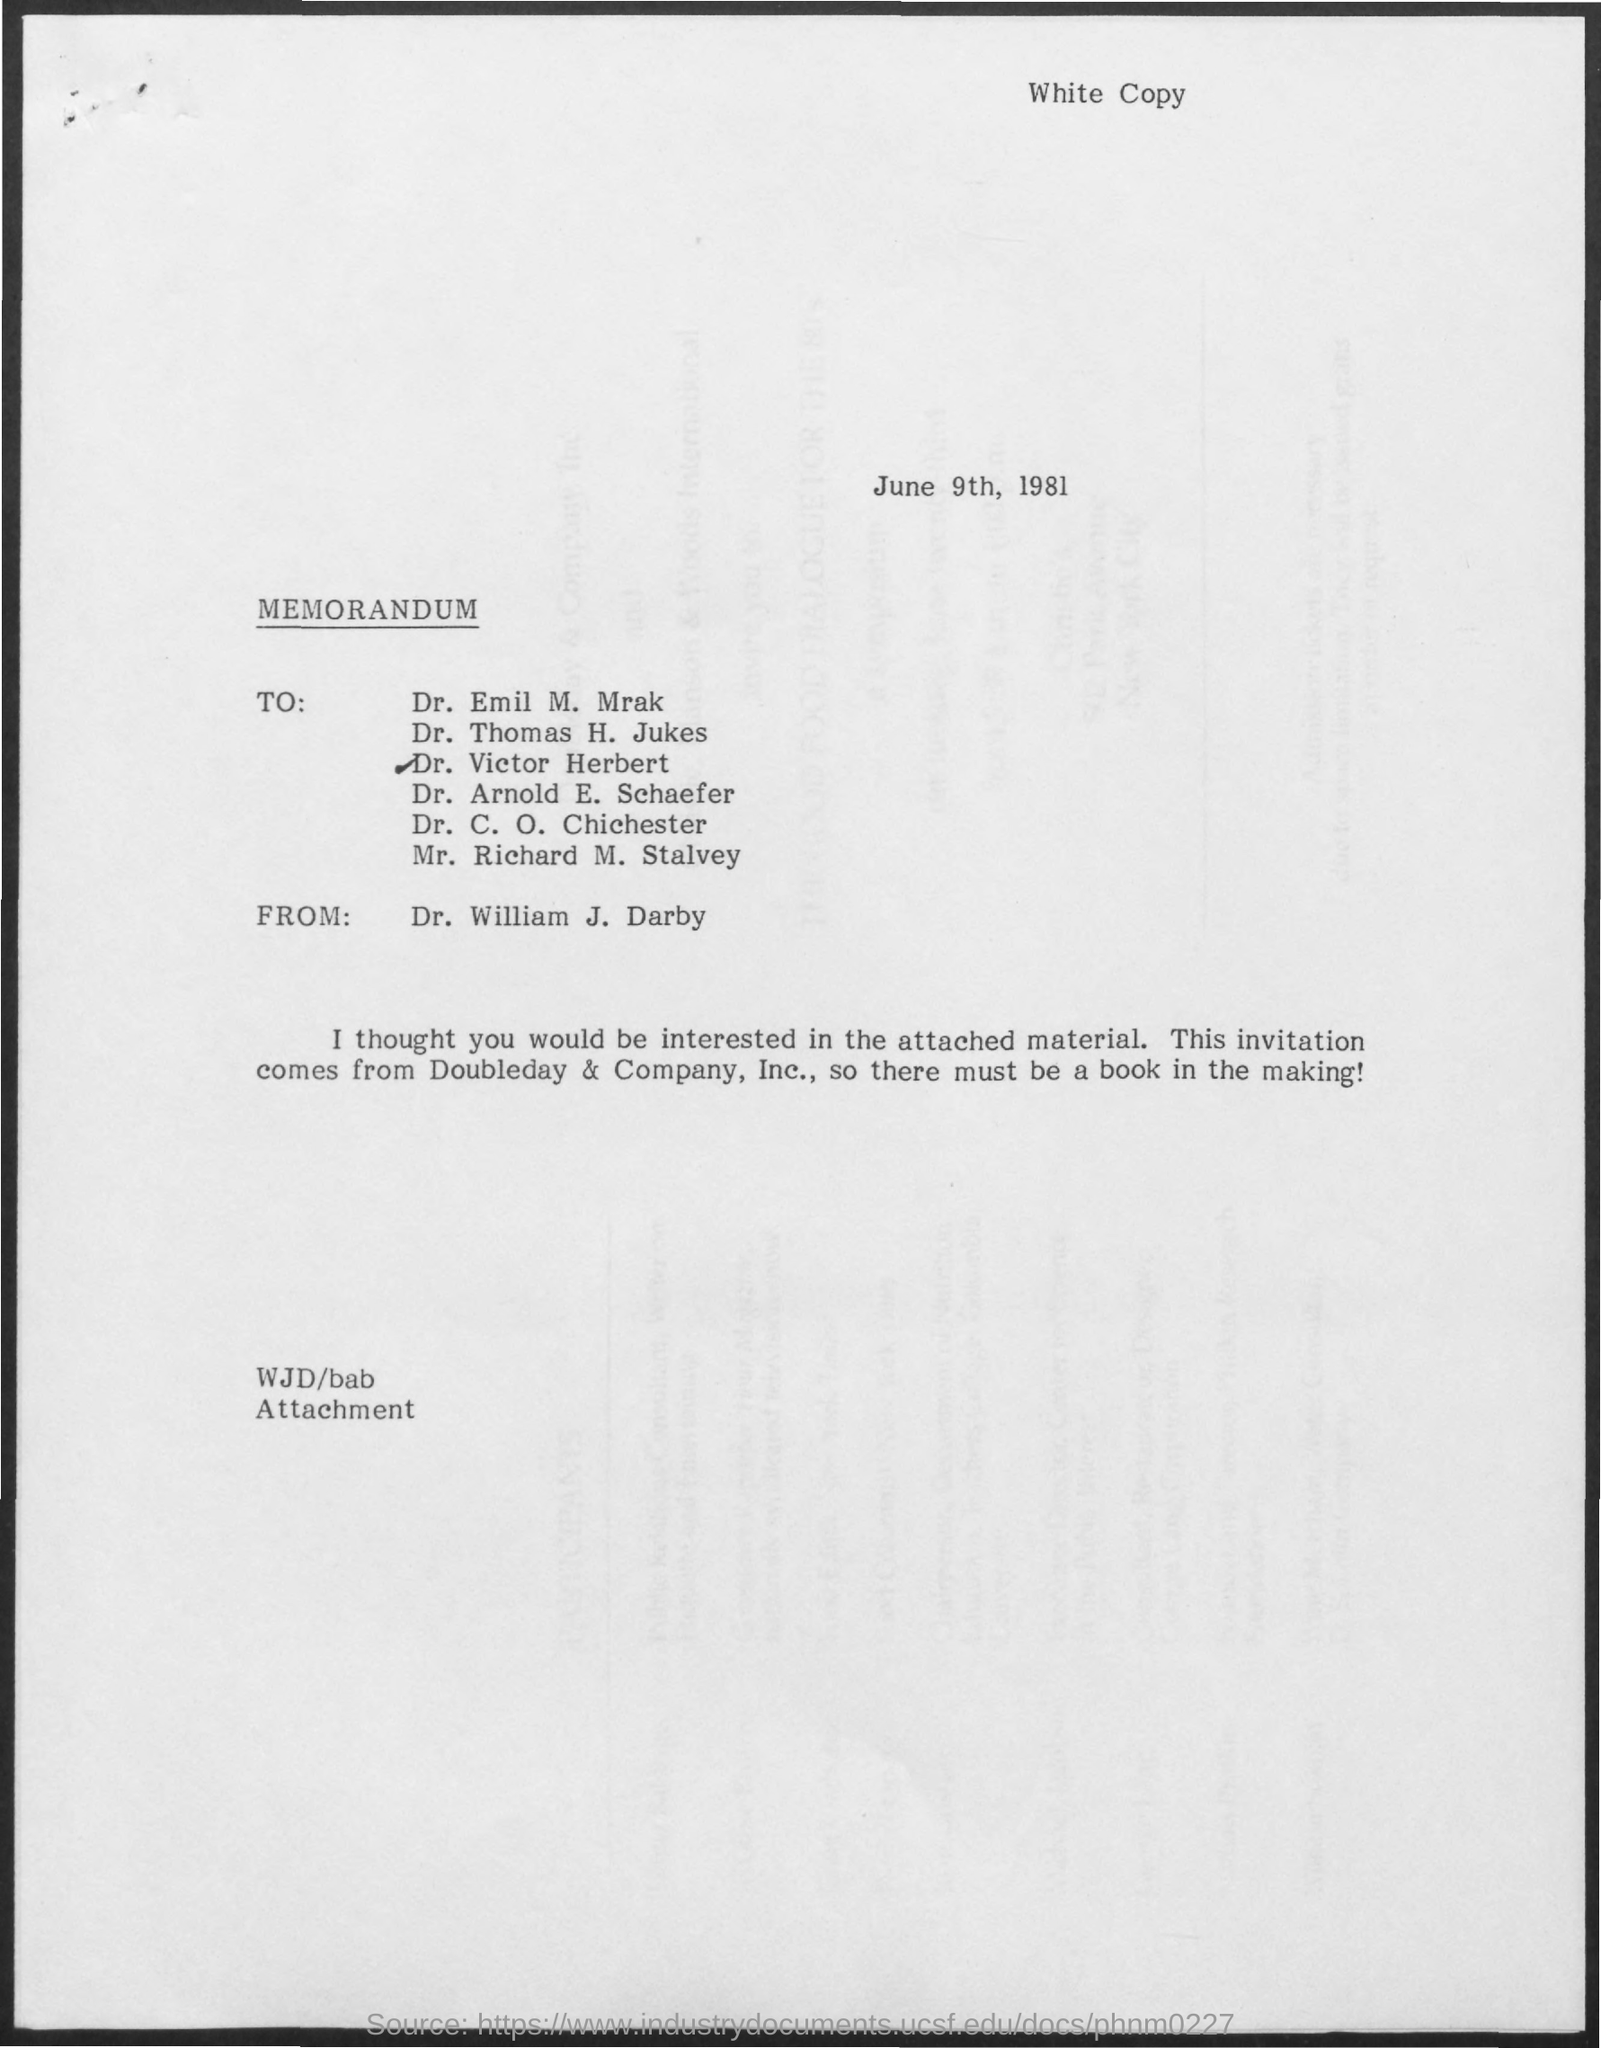Outline some significant characteristics in this image. The memorandum was sent from Dr. William J. Darby. The date mentioned in the given page is June 9th, 1981. 